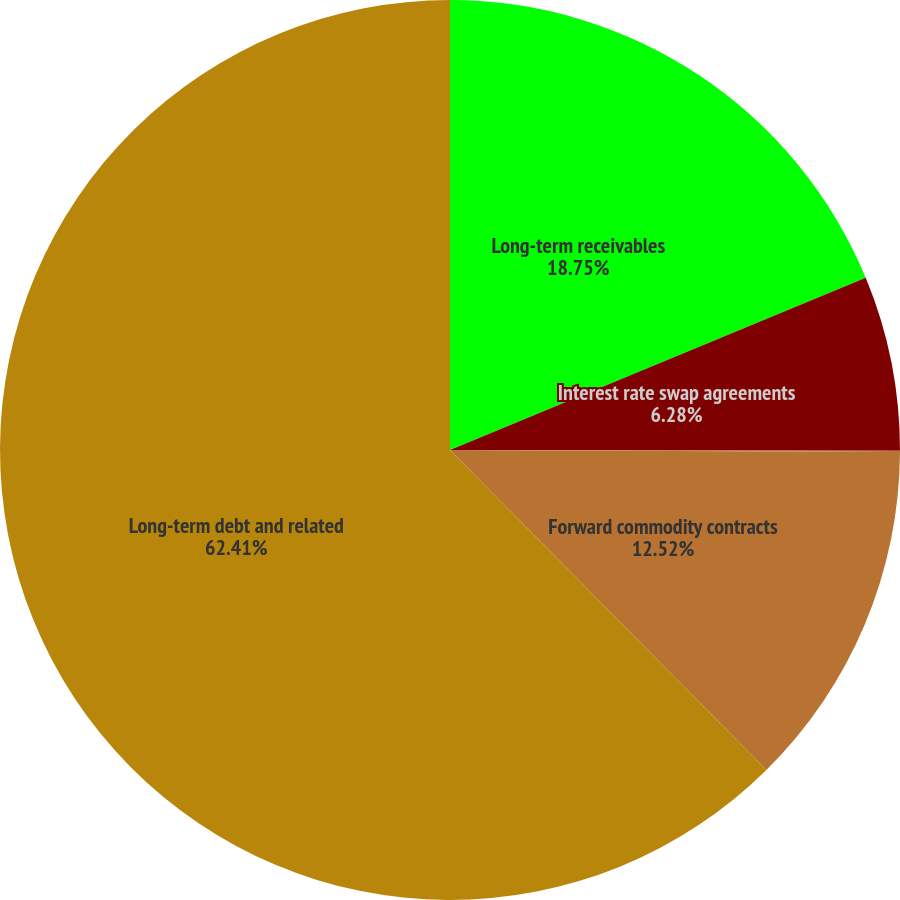Convert chart to OTSL. <chart><loc_0><loc_0><loc_500><loc_500><pie_chart><fcel>Long-term receivables<fcel>Interest rate swap agreements<fcel>Foreign currency exchange<fcel>Forward commodity contracts<fcel>Long-term debt and related<nl><fcel>18.75%<fcel>6.28%<fcel>0.04%<fcel>12.52%<fcel>62.41%<nl></chart> 